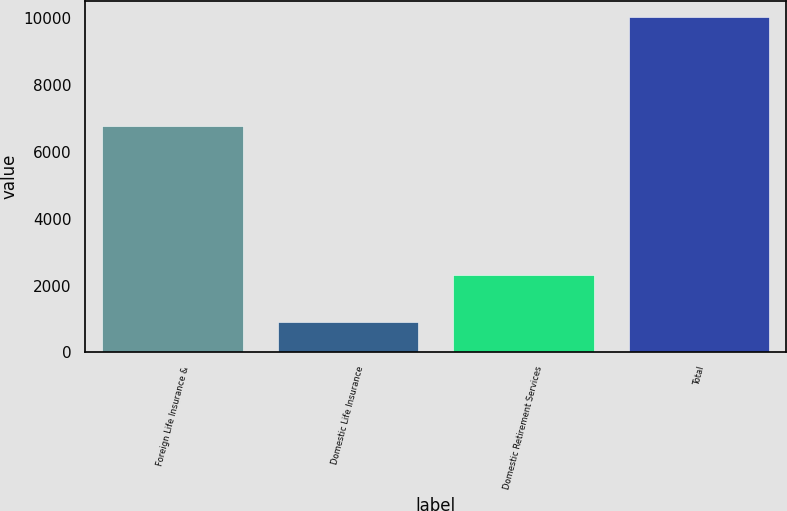Convert chart to OTSL. <chart><loc_0><loc_0><loc_500><loc_500><bar_chart><fcel>Foreign Life Insurance &<fcel>Domestic Life Insurance<fcel>Domestic Retirement Services<fcel>Total<nl><fcel>6792<fcel>917<fcel>2323<fcel>10032<nl></chart> 